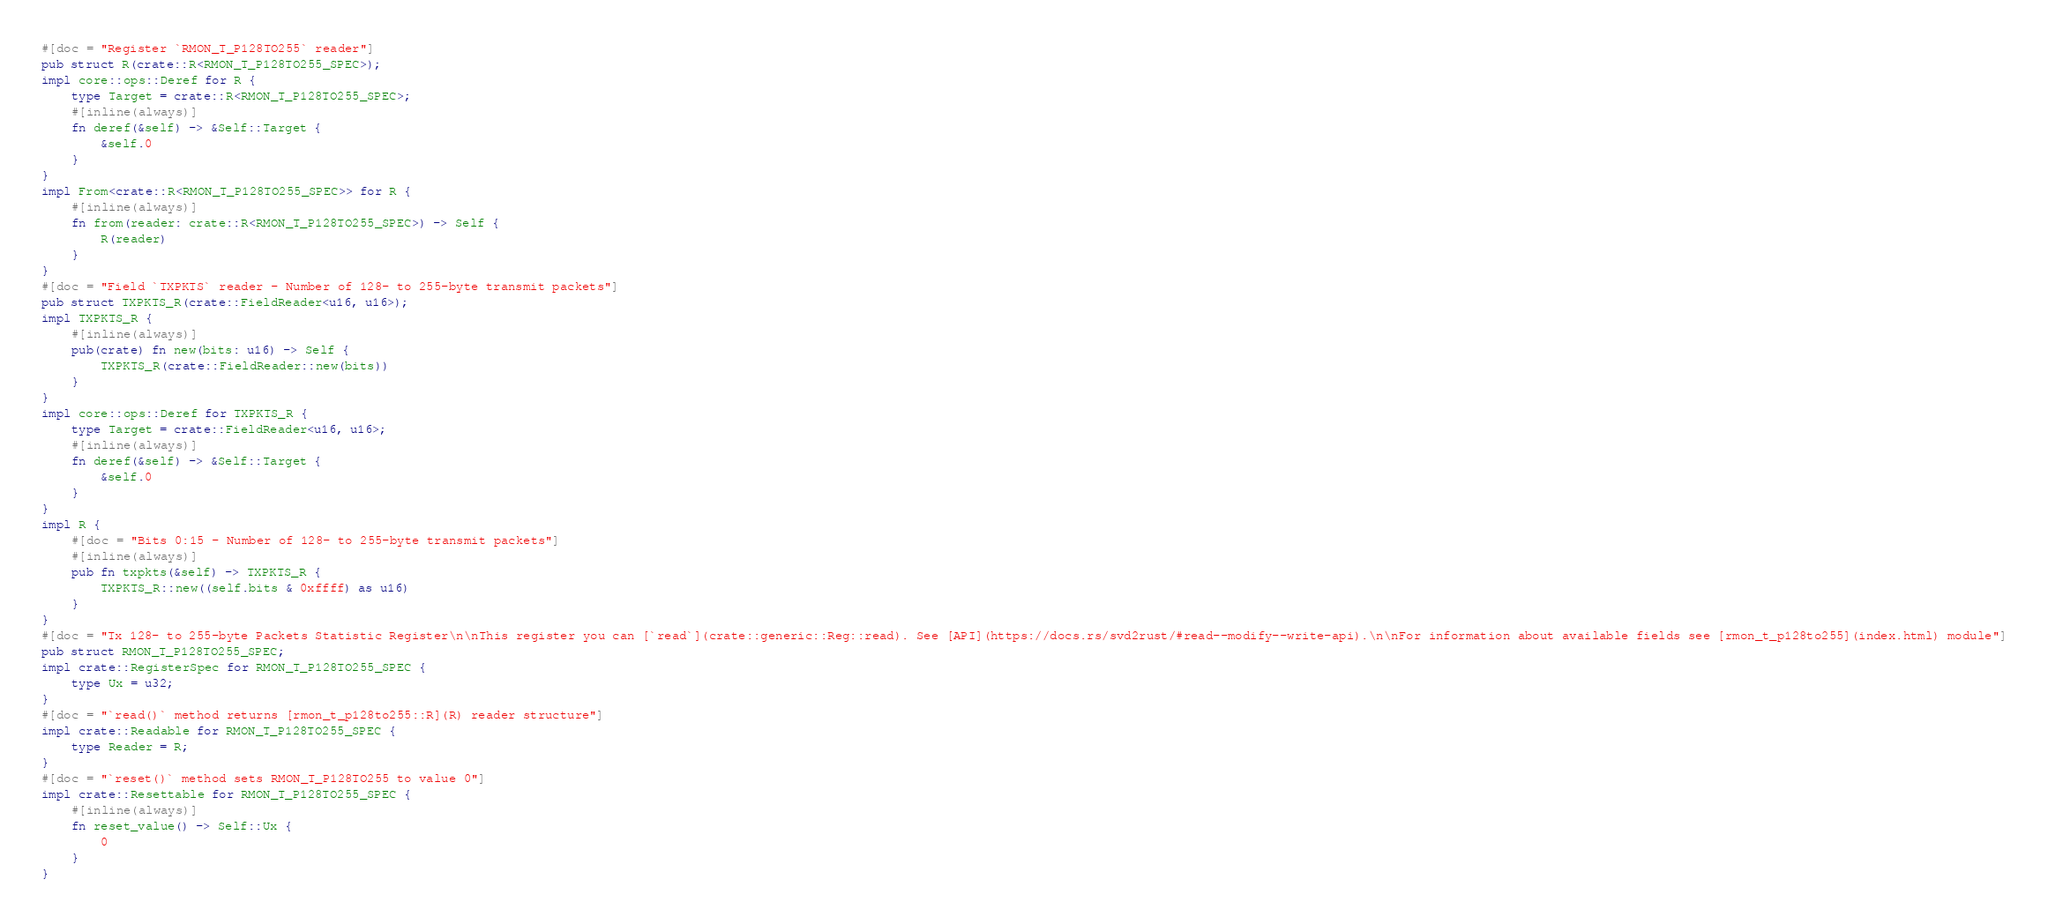Convert code to text. <code><loc_0><loc_0><loc_500><loc_500><_Rust_>#[doc = "Register `RMON_T_P128TO255` reader"]
pub struct R(crate::R<RMON_T_P128TO255_SPEC>);
impl core::ops::Deref for R {
    type Target = crate::R<RMON_T_P128TO255_SPEC>;
    #[inline(always)]
    fn deref(&self) -> &Self::Target {
        &self.0
    }
}
impl From<crate::R<RMON_T_P128TO255_SPEC>> for R {
    #[inline(always)]
    fn from(reader: crate::R<RMON_T_P128TO255_SPEC>) -> Self {
        R(reader)
    }
}
#[doc = "Field `TXPKTS` reader - Number of 128- to 255-byte transmit packets"]
pub struct TXPKTS_R(crate::FieldReader<u16, u16>);
impl TXPKTS_R {
    #[inline(always)]
    pub(crate) fn new(bits: u16) -> Self {
        TXPKTS_R(crate::FieldReader::new(bits))
    }
}
impl core::ops::Deref for TXPKTS_R {
    type Target = crate::FieldReader<u16, u16>;
    #[inline(always)]
    fn deref(&self) -> &Self::Target {
        &self.0
    }
}
impl R {
    #[doc = "Bits 0:15 - Number of 128- to 255-byte transmit packets"]
    #[inline(always)]
    pub fn txpkts(&self) -> TXPKTS_R {
        TXPKTS_R::new((self.bits & 0xffff) as u16)
    }
}
#[doc = "Tx 128- to 255-byte Packets Statistic Register\n\nThis register you can [`read`](crate::generic::Reg::read). See [API](https://docs.rs/svd2rust/#read--modify--write-api).\n\nFor information about available fields see [rmon_t_p128to255](index.html) module"]
pub struct RMON_T_P128TO255_SPEC;
impl crate::RegisterSpec for RMON_T_P128TO255_SPEC {
    type Ux = u32;
}
#[doc = "`read()` method returns [rmon_t_p128to255::R](R) reader structure"]
impl crate::Readable for RMON_T_P128TO255_SPEC {
    type Reader = R;
}
#[doc = "`reset()` method sets RMON_T_P128TO255 to value 0"]
impl crate::Resettable for RMON_T_P128TO255_SPEC {
    #[inline(always)]
    fn reset_value() -> Self::Ux {
        0
    }
}
</code> 